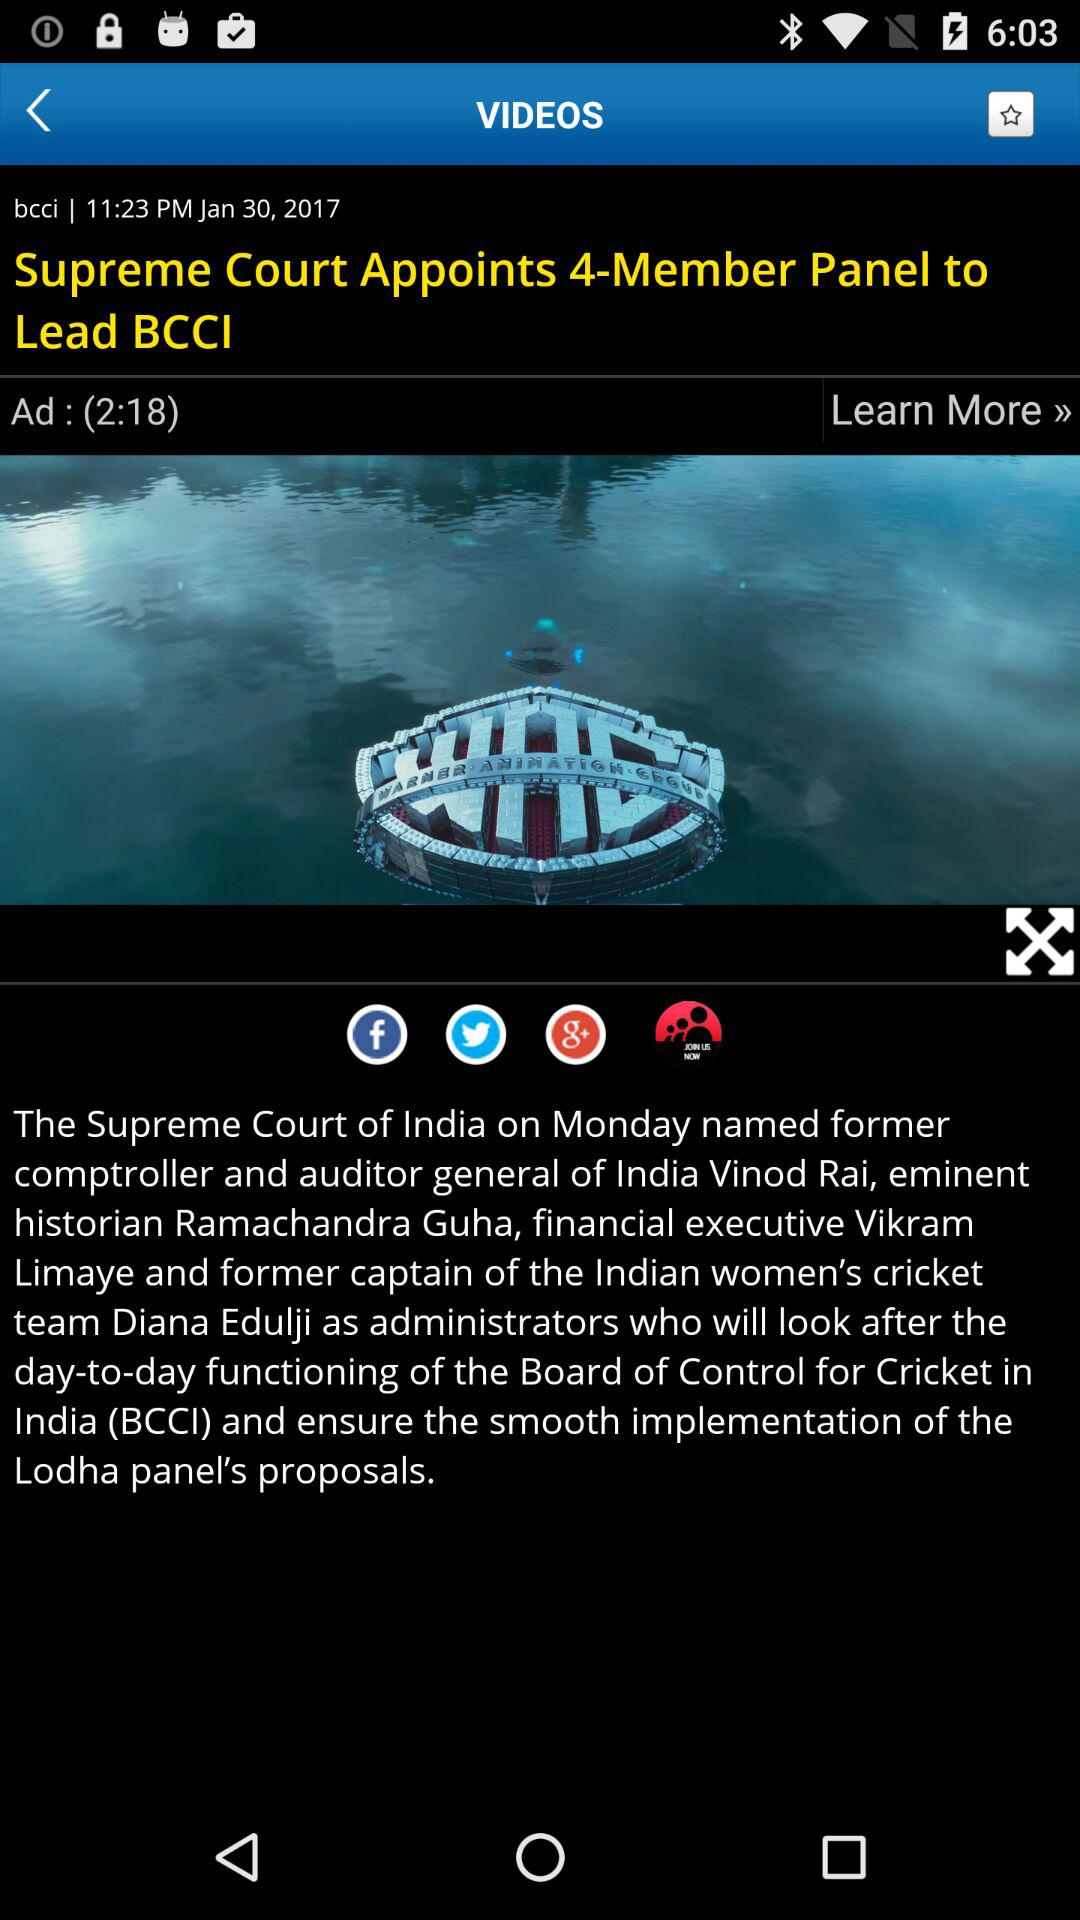What is the date? The date is January 30, 2017. 